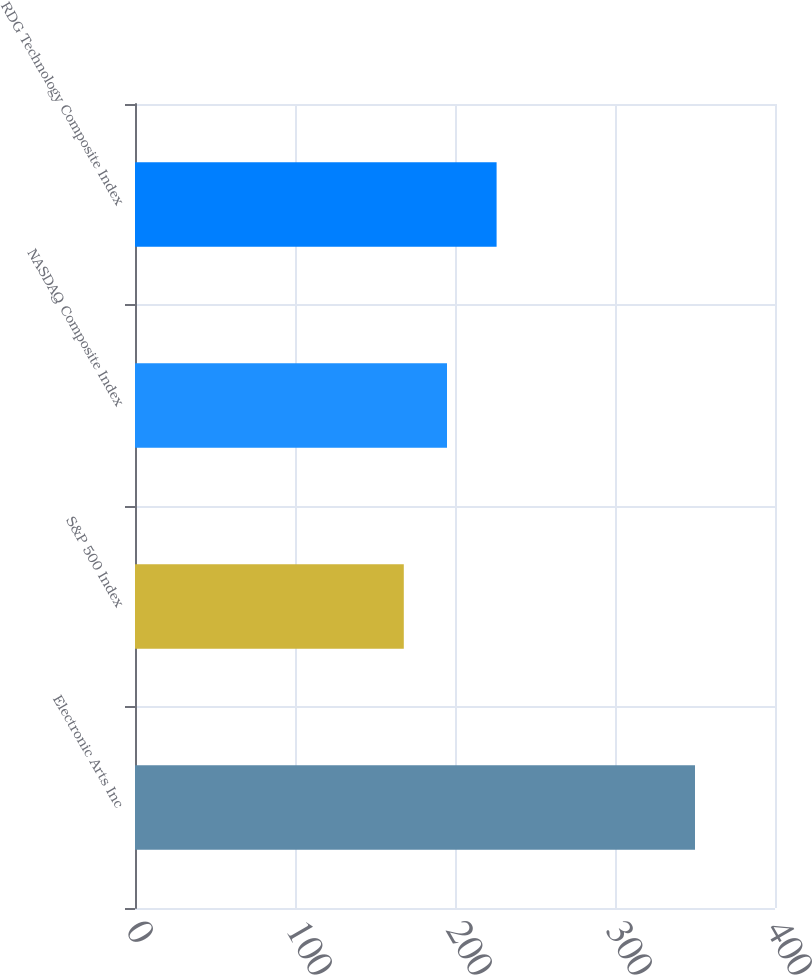Convert chart to OTSL. <chart><loc_0><loc_0><loc_500><loc_500><bar_chart><fcel>Electronic Arts Inc<fcel>S&P 500 Index<fcel>NASDAQ Composite Index<fcel>RDG Technology Composite Index<nl><fcel>350<fcel>168<fcel>195<fcel>226<nl></chart> 